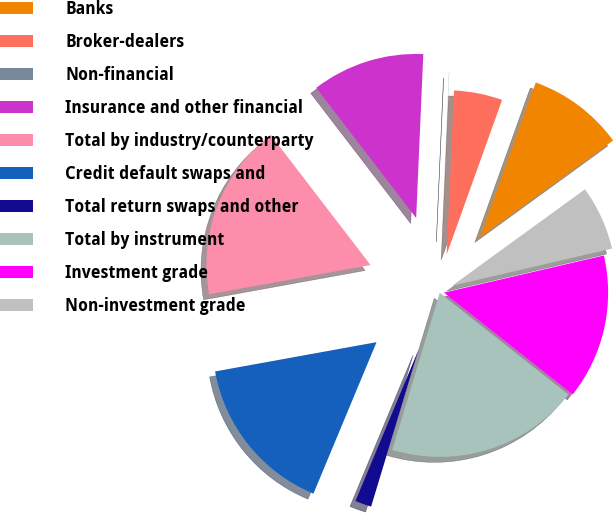Convert chart to OTSL. <chart><loc_0><loc_0><loc_500><loc_500><pie_chart><fcel>Banks<fcel>Broker-dealers<fcel>Non-financial<fcel>Insurance and other financial<fcel>Total by industry/counterparty<fcel>Credit default swaps and<fcel>Total return swaps and other<fcel>Total by instrument<fcel>Investment grade<fcel>Non-investment grade<nl><fcel>9.52%<fcel>4.77%<fcel>0.02%<fcel>11.11%<fcel>17.44%<fcel>15.86%<fcel>1.61%<fcel>19.03%<fcel>14.28%<fcel>6.36%<nl></chart> 